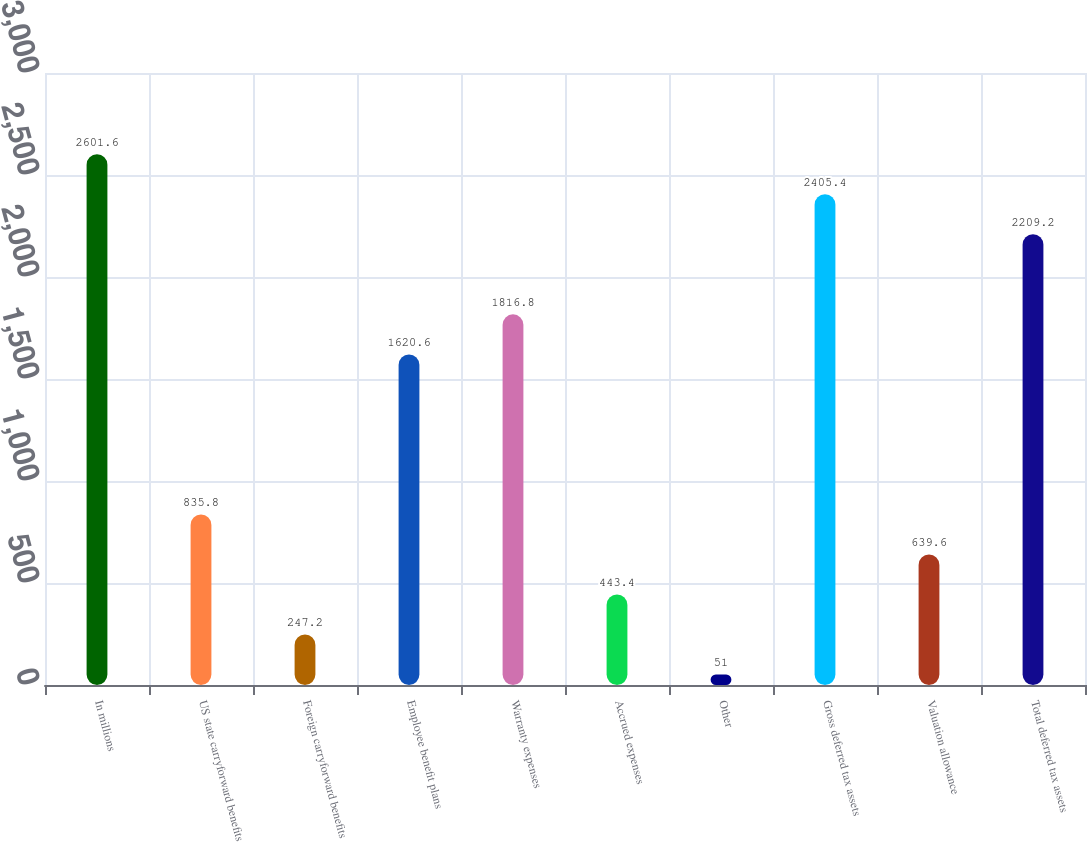Convert chart to OTSL. <chart><loc_0><loc_0><loc_500><loc_500><bar_chart><fcel>In millions<fcel>US state carryforward benefits<fcel>Foreign carryforward benefits<fcel>Employee benefit plans<fcel>Warranty expenses<fcel>Accrued expenses<fcel>Other<fcel>Gross deferred tax assets<fcel>Valuation allowance<fcel>Total deferred tax assets<nl><fcel>2601.6<fcel>835.8<fcel>247.2<fcel>1620.6<fcel>1816.8<fcel>443.4<fcel>51<fcel>2405.4<fcel>639.6<fcel>2209.2<nl></chart> 